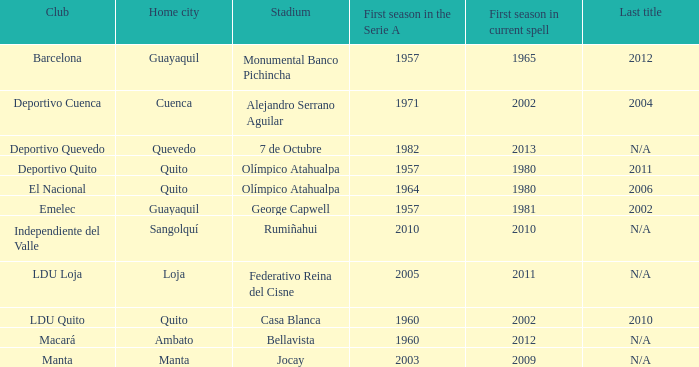Name the last title for cuenca 2004.0. 